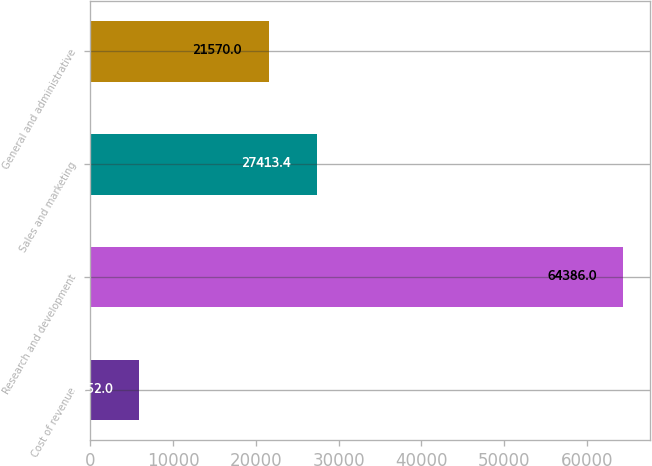<chart> <loc_0><loc_0><loc_500><loc_500><bar_chart><fcel>Cost of revenue<fcel>Research and development<fcel>Sales and marketing<fcel>General and administrative<nl><fcel>5952<fcel>64386<fcel>27413.4<fcel>21570<nl></chart> 